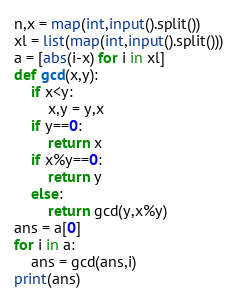Convert code to text. <code><loc_0><loc_0><loc_500><loc_500><_Python_>n,x = map(int,input().split())
xl = list(map(int,input().split()))
a = [abs(i-x) for i in xl]
def gcd(x,y):
    if x<y:
        x,y = y,x
    if y==0:
        return x
    if x%y==0:
        return y
    else:
        return gcd(y,x%y)
ans = a[0]
for i in a:
    ans = gcd(ans,i)
print(ans)</code> 